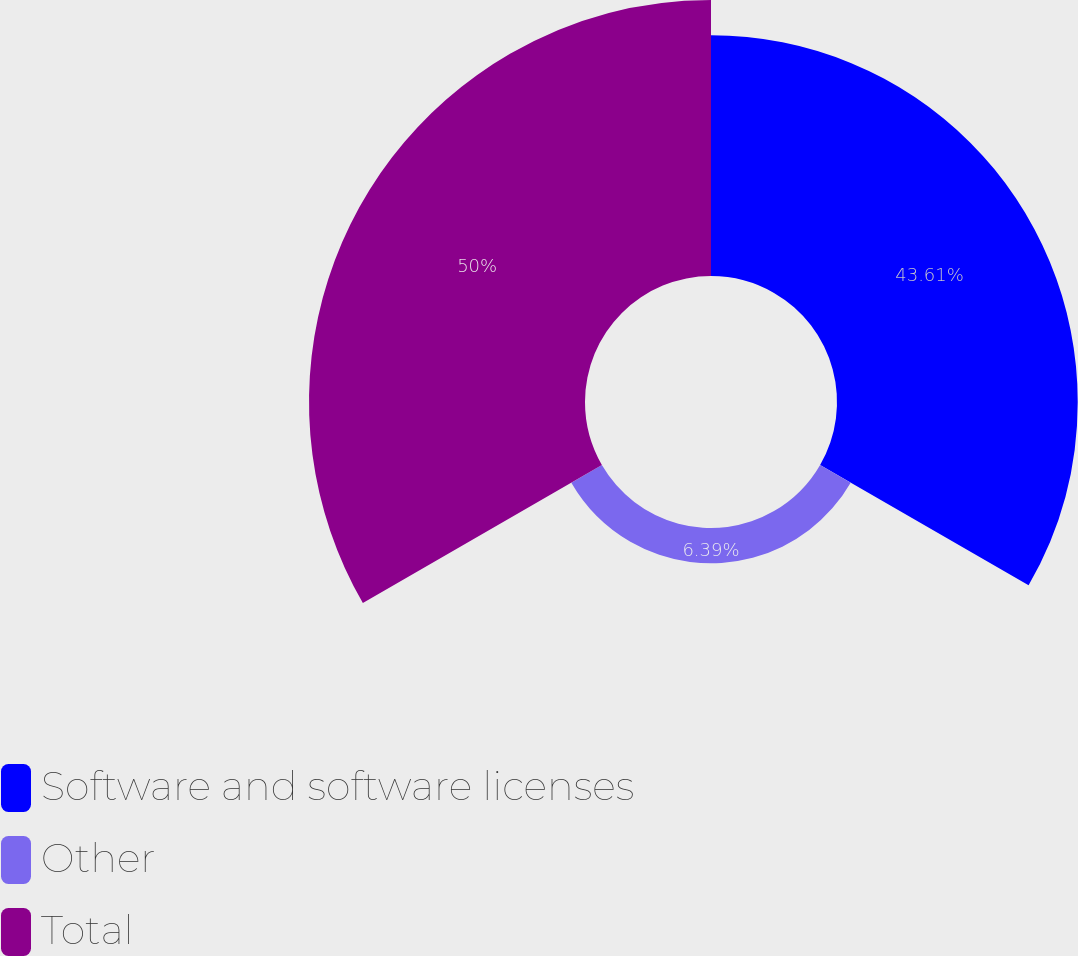Convert chart to OTSL. <chart><loc_0><loc_0><loc_500><loc_500><pie_chart><fcel>Software and software licenses<fcel>Other<fcel>Total<nl><fcel>43.61%<fcel>6.39%<fcel>50.0%<nl></chart> 